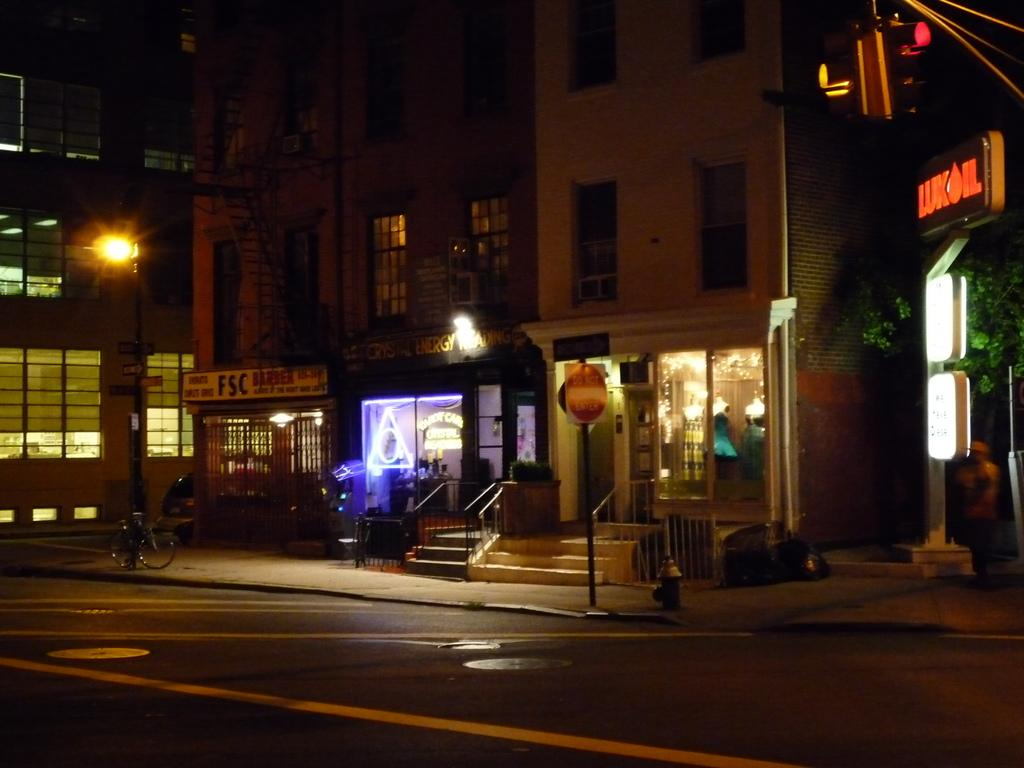What type of structures can be seen in the image? There are buildings in the image. What can be seen illuminating the area in the image? There are lights in the image. What type of establishments are present in the image? There are stores in the image. What architectural feature is present in the image? There are stairs in the image. What type of vegetation is visible in the image? There are trees in the image. What type of transportation infrastructure is present in the image? There is a road in the image. What mode of transportation can be seen in the image? There is a bicycle in the image. What device is used to control traffic in the image? There is a traffic signal in the image. Where is the wrench being used in the image? There is no wrench present in the image. What type of vegetable is being harvested from the trees in the image? There are no vegetables being harvested from the trees in the image; the trees are not depicted as bearing fruit or vegetables. 